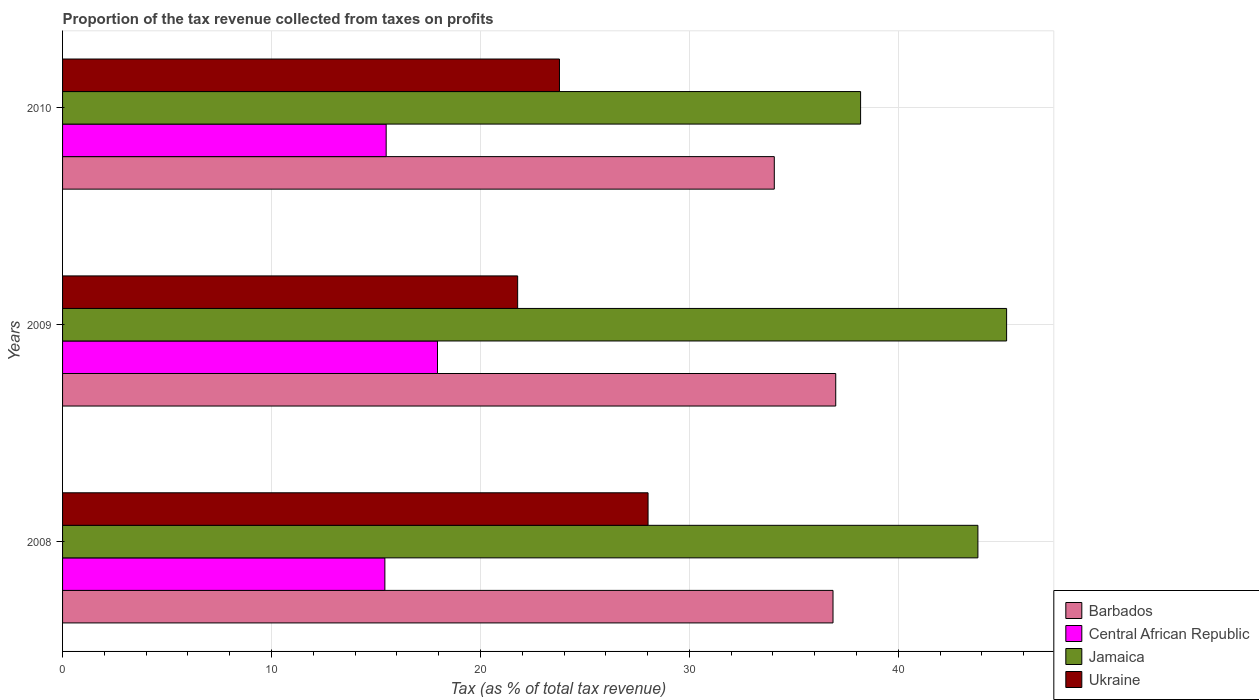How many different coloured bars are there?
Provide a short and direct response. 4. Are the number of bars on each tick of the Y-axis equal?
Your response must be concise. Yes. What is the label of the 3rd group of bars from the top?
Your answer should be very brief. 2008. In how many cases, is the number of bars for a given year not equal to the number of legend labels?
Keep it short and to the point. 0. What is the proportion of the tax revenue collected in Ukraine in 2009?
Your response must be concise. 21.78. Across all years, what is the maximum proportion of the tax revenue collected in Barbados?
Your response must be concise. 37.01. Across all years, what is the minimum proportion of the tax revenue collected in Ukraine?
Your response must be concise. 21.78. In which year was the proportion of the tax revenue collected in Jamaica minimum?
Make the answer very short. 2010. What is the total proportion of the tax revenue collected in Jamaica in the graph?
Your answer should be very brief. 127.19. What is the difference between the proportion of the tax revenue collected in Central African Republic in 2008 and that in 2009?
Give a very brief answer. -2.52. What is the difference between the proportion of the tax revenue collected in Central African Republic in 2010 and the proportion of the tax revenue collected in Jamaica in 2009?
Provide a short and direct response. -29.7. What is the average proportion of the tax revenue collected in Ukraine per year?
Your response must be concise. 24.53. In the year 2008, what is the difference between the proportion of the tax revenue collected in Ukraine and proportion of the tax revenue collected in Central African Republic?
Offer a terse response. 12.6. What is the ratio of the proportion of the tax revenue collected in Barbados in 2009 to that in 2010?
Make the answer very short. 1.09. Is the proportion of the tax revenue collected in Ukraine in 2009 less than that in 2010?
Your answer should be compact. Yes. What is the difference between the highest and the second highest proportion of the tax revenue collected in Barbados?
Provide a short and direct response. 0.13. What is the difference between the highest and the lowest proportion of the tax revenue collected in Ukraine?
Provide a succinct answer. 6.24. In how many years, is the proportion of the tax revenue collected in Ukraine greater than the average proportion of the tax revenue collected in Ukraine taken over all years?
Provide a succinct answer. 1. What does the 1st bar from the top in 2009 represents?
Keep it short and to the point. Ukraine. What does the 4th bar from the bottom in 2010 represents?
Make the answer very short. Ukraine. Is it the case that in every year, the sum of the proportion of the tax revenue collected in Barbados and proportion of the tax revenue collected in Jamaica is greater than the proportion of the tax revenue collected in Ukraine?
Your answer should be very brief. Yes. How many bars are there?
Offer a very short reply. 12. Are all the bars in the graph horizontal?
Your response must be concise. Yes. What is the title of the graph?
Your answer should be compact. Proportion of the tax revenue collected from taxes on profits. Does "Bolivia" appear as one of the legend labels in the graph?
Your response must be concise. No. What is the label or title of the X-axis?
Your response must be concise. Tax (as % of total tax revenue). What is the Tax (as % of total tax revenue) in Barbados in 2008?
Your answer should be compact. 36.88. What is the Tax (as % of total tax revenue) of Central African Republic in 2008?
Your response must be concise. 15.43. What is the Tax (as % of total tax revenue) in Jamaica in 2008?
Provide a short and direct response. 43.81. What is the Tax (as % of total tax revenue) in Ukraine in 2008?
Offer a terse response. 28.02. What is the Tax (as % of total tax revenue) in Barbados in 2009?
Your answer should be compact. 37.01. What is the Tax (as % of total tax revenue) in Central African Republic in 2009?
Your answer should be compact. 17.95. What is the Tax (as % of total tax revenue) of Jamaica in 2009?
Your answer should be very brief. 45.18. What is the Tax (as % of total tax revenue) of Ukraine in 2009?
Offer a terse response. 21.78. What is the Tax (as % of total tax revenue) in Barbados in 2010?
Your response must be concise. 34.07. What is the Tax (as % of total tax revenue) of Central African Republic in 2010?
Provide a succinct answer. 15.49. What is the Tax (as % of total tax revenue) in Jamaica in 2010?
Your answer should be very brief. 38.2. What is the Tax (as % of total tax revenue) of Ukraine in 2010?
Make the answer very short. 23.78. Across all years, what is the maximum Tax (as % of total tax revenue) in Barbados?
Your answer should be very brief. 37.01. Across all years, what is the maximum Tax (as % of total tax revenue) in Central African Republic?
Provide a succinct answer. 17.95. Across all years, what is the maximum Tax (as % of total tax revenue) of Jamaica?
Provide a short and direct response. 45.18. Across all years, what is the maximum Tax (as % of total tax revenue) in Ukraine?
Give a very brief answer. 28.02. Across all years, what is the minimum Tax (as % of total tax revenue) in Barbados?
Provide a short and direct response. 34.07. Across all years, what is the minimum Tax (as % of total tax revenue) of Central African Republic?
Ensure brevity in your answer.  15.43. Across all years, what is the minimum Tax (as % of total tax revenue) in Jamaica?
Provide a succinct answer. 38.2. Across all years, what is the minimum Tax (as % of total tax revenue) of Ukraine?
Offer a very short reply. 21.78. What is the total Tax (as % of total tax revenue) of Barbados in the graph?
Keep it short and to the point. 107.95. What is the total Tax (as % of total tax revenue) in Central African Republic in the graph?
Your answer should be very brief. 48.86. What is the total Tax (as % of total tax revenue) in Jamaica in the graph?
Offer a very short reply. 127.19. What is the total Tax (as % of total tax revenue) of Ukraine in the graph?
Your answer should be compact. 73.59. What is the difference between the Tax (as % of total tax revenue) of Barbados in 2008 and that in 2009?
Your answer should be compact. -0.13. What is the difference between the Tax (as % of total tax revenue) in Central African Republic in 2008 and that in 2009?
Your answer should be very brief. -2.52. What is the difference between the Tax (as % of total tax revenue) of Jamaica in 2008 and that in 2009?
Offer a very short reply. -1.37. What is the difference between the Tax (as % of total tax revenue) of Ukraine in 2008 and that in 2009?
Provide a short and direct response. 6.24. What is the difference between the Tax (as % of total tax revenue) in Barbados in 2008 and that in 2010?
Make the answer very short. 2.81. What is the difference between the Tax (as % of total tax revenue) in Central African Republic in 2008 and that in 2010?
Provide a succinct answer. -0.06. What is the difference between the Tax (as % of total tax revenue) in Jamaica in 2008 and that in 2010?
Offer a terse response. 5.61. What is the difference between the Tax (as % of total tax revenue) of Ukraine in 2008 and that in 2010?
Ensure brevity in your answer.  4.24. What is the difference between the Tax (as % of total tax revenue) in Barbados in 2009 and that in 2010?
Give a very brief answer. 2.94. What is the difference between the Tax (as % of total tax revenue) of Central African Republic in 2009 and that in 2010?
Your answer should be very brief. 2.46. What is the difference between the Tax (as % of total tax revenue) in Jamaica in 2009 and that in 2010?
Make the answer very short. 6.99. What is the difference between the Tax (as % of total tax revenue) in Ukraine in 2009 and that in 2010?
Provide a short and direct response. -2. What is the difference between the Tax (as % of total tax revenue) of Barbados in 2008 and the Tax (as % of total tax revenue) of Central African Republic in 2009?
Give a very brief answer. 18.93. What is the difference between the Tax (as % of total tax revenue) of Barbados in 2008 and the Tax (as % of total tax revenue) of Jamaica in 2009?
Provide a short and direct response. -8.31. What is the difference between the Tax (as % of total tax revenue) in Barbados in 2008 and the Tax (as % of total tax revenue) in Ukraine in 2009?
Offer a very short reply. 15.09. What is the difference between the Tax (as % of total tax revenue) in Central African Republic in 2008 and the Tax (as % of total tax revenue) in Jamaica in 2009?
Ensure brevity in your answer.  -29.76. What is the difference between the Tax (as % of total tax revenue) in Central African Republic in 2008 and the Tax (as % of total tax revenue) in Ukraine in 2009?
Offer a terse response. -6.35. What is the difference between the Tax (as % of total tax revenue) in Jamaica in 2008 and the Tax (as % of total tax revenue) in Ukraine in 2009?
Provide a succinct answer. 22.03. What is the difference between the Tax (as % of total tax revenue) of Barbados in 2008 and the Tax (as % of total tax revenue) of Central African Republic in 2010?
Your response must be concise. 21.39. What is the difference between the Tax (as % of total tax revenue) in Barbados in 2008 and the Tax (as % of total tax revenue) in Jamaica in 2010?
Your response must be concise. -1.32. What is the difference between the Tax (as % of total tax revenue) of Barbados in 2008 and the Tax (as % of total tax revenue) of Ukraine in 2010?
Provide a short and direct response. 13.09. What is the difference between the Tax (as % of total tax revenue) of Central African Republic in 2008 and the Tax (as % of total tax revenue) of Jamaica in 2010?
Provide a succinct answer. -22.77. What is the difference between the Tax (as % of total tax revenue) in Central African Republic in 2008 and the Tax (as % of total tax revenue) in Ukraine in 2010?
Your answer should be very brief. -8.36. What is the difference between the Tax (as % of total tax revenue) of Jamaica in 2008 and the Tax (as % of total tax revenue) of Ukraine in 2010?
Provide a succinct answer. 20.03. What is the difference between the Tax (as % of total tax revenue) of Barbados in 2009 and the Tax (as % of total tax revenue) of Central African Republic in 2010?
Offer a terse response. 21.52. What is the difference between the Tax (as % of total tax revenue) of Barbados in 2009 and the Tax (as % of total tax revenue) of Jamaica in 2010?
Keep it short and to the point. -1.19. What is the difference between the Tax (as % of total tax revenue) of Barbados in 2009 and the Tax (as % of total tax revenue) of Ukraine in 2010?
Make the answer very short. 13.22. What is the difference between the Tax (as % of total tax revenue) of Central African Republic in 2009 and the Tax (as % of total tax revenue) of Jamaica in 2010?
Your answer should be very brief. -20.25. What is the difference between the Tax (as % of total tax revenue) in Central African Republic in 2009 and the Tax (as % of total tax revenue) in Ukraine in 2010?
Make the answer very short. -5.84. What is the difference between the Tax (as % of total tax revenue) in Jamaica in 2009 and the Tax (as % of total tax revenue) in Ukraine in 2010?
Offer a terse response. 21.4. What is the average Tax (as % of total tax revenue) in Barbados per year?
Your answer should be compact. 35.98. What is the average Tax (as % of total tax revenue) of Central African Republic per year?
Provide a short and direct response. 16.29. What is the average Tax (as % of total tax revenue) in Jamaica per year?
Give a very brief answer. 42.4. What is the average Tax (as % of total tax revenue) of Ukraine per year?
Give a very brief answer. 24.53. In the year 2008, what is the difference between the Tax (as % of total tax revenue) in Barbados and Tax (as % of total tax revenue) in Central African Republic?
Provide a short and direct response. 21.45. In the year 2008, what is the difference between the Tax (as % of total tax revenue) of Barbados and Tax (as % of total tax revenue) of Jamaica?
Provide a succinct answer. -6.93. In the year 2008, what is the difference between the Tax (as % of total tax revenue) of Barbados and Tax (as % of total tax revenue) of Ukraine?
Make the answer very short. 8.85. In the year 2008, what is the difference between the Tax (as % of total tax revenue) in Central African Republic and Tax (as % of total tax revenue) in Jamaica?
Offer a very short reply. -28.38. In the year 2008, what is the difference between the Tax (as % of total tax revenue) of Central African Republic and Tax (as % of total tax revenue) of Ukraine?
Provide a short and direct response. -12.6. In the year 2008, what is the difference between the Tax (as % of total tax revenue) of Jamaica and Tax (as % of total tax revenue) of Ukraine?
Your response must be concise. 15.79. In the year 2009, what is the difference between the Tax (as % of total tax revenue) of Barbados and Tax (as % of total tax revenue) of Central African Republic?
Ensure brevity in your answer.  19.06. In the year 2009, what is the difference between the Tax (as % of total tax revenue) in Barbados and Tax (as % of total tax revenue) in Jamaica?
Make the answer very short. -8.18. In the year 2009, what is the difference between the Tax (as % of total tax revenue) in Barbados and Tax (as % of total tax revenue) in Ukraine?
Keep it short and to the point. 15.22. In the year 2009, what is the difference between the Tax (as % of total tax revenue) of Central African Republic and Tax (as % of total tax revenue) of Jamaica?
Provide a succinct answer. -27.24. In the year 2009, what is the difference between the Tax (as % of total tax revenue) in Central African Republic and Tax (as % of total tax revenue) in Ukraine?
Give a very brief answer. -3.84. In the year 2009, what is the difference between the Tax (as % of total tax revenue) of Jamaica and Tax (as % of total tax revenue) of Ukraine?
Keep it short and to the point. 23.4. In the year 2010, what is the difference between the Tax (as % of total tax revenue) in Barbados and Tax (as % of total tax revenue) in Central African Republic?
Your response must be concise. 18.58. In the year 2010, what is the difference between the Tax (as % of total tax revenue) in Barbados and Tax (as % of total tax revenue) in Jamaica?
Your answer should be very brief. -4.13. In the year 2010, what is the difference between the Tax (as % of total tax revenue) of Barbados and Tax (as % of total tax revenue) of Ukraine?
Provide a succinct answer. 10.28. In the year 2010, what is the difference between the Tax (as % of total tax revenue) of Central African Republic and Tax (as % of total tax revenue) of Jamaica?
Offer a terse response. -22.71. In the year 2010, what is the difference between the Tax (as % of total tax revenue) in Central African Republic and Tax (as % of total tax revenue) in Ukraine?
Provide a succinct answer. -8.29. In the year 2010, what is the difference between the Tax (as % of total tax revenue) of Jamaica and Tax (as % of total tax revenue) of Ukraine?
Provide a succinct answer. 14.41. What is the ratio of the Tax (as % of total tax revenue) in Central African Republic in 2008 to that in 2009?
Your response must be concise. 0.86. What is the ratio of the Tax (as % of total tax revenue) of Jamaica in 2008 to that in 2009?
Your response must be concise. 0.97. What is the ratio of the Tax (as % of total tax revenue) of Ukraine in 2008 to that in 2009?
Give a very brief answer. 1.29. What is the ratio of the Tax (as % of total tax revenue) in Barbados in 2008 to that in 2010?
Provide a short and direct response. 1.08. What is the ratio of the Tax (as % of total tax revenue) of Jamaica in 2008 to that in 2010?
Provide a short and direct response. 1.15. What is the ratio of the Tax (as % of total tax revenue) in Ukraine in 2008 to that in 2010?
Ensure brevity in your answer.  1.18. What is the ratio of the Tax (as % of total tax revenue) of Barbados in 2009 to that in 2010?
Keep it short and to the point. 1.09. What is the ratio of the Tax (as % of total tax revenue) in Central African Republic in 2009 to that in 2010?
Provide a succinct answer. 1.16. What is the ratio of the Tax (as % of total tax revenue) of Jamaica in 2009 to that in 2010?
Your answer should be very brief. 1.18. What is the ratio of the Tax (as % of total tax revenue) of Ukraine in 2009 to that in 2010?
Ensure brevity in your answer.  0.92. What is the difference between the highest and the second highest Tax (as % of total tax revenue) in Barbados?
Provide a succinct answer. 0.13. What is the difference between the highest and the second highest Tax (as % of total tax revenue) of Central African Republic?
Ensure brevity in your answer.  2.46. What is the difference between the highest and the second highest Tax (as % of total tax revenue) of Jamaica?
Provide a succinct answer. 1.37. What is the difference between the highest and the second highest Tax (as % of total tax revenue) of Ukraine?
Make the answer very short. 4.24. What is the difference between the highest and the lowest Tax (as % of total tax revenue) in Barbados?
Offer a very short reply. 2.94. What is the difference between the highest and the lowest Tax (as % of total tax revenue) of Central African Republic?
Your answer should be compact. 2.52. What is the difference between the highest and the lowest Tax (as % of total tax revenue) of Jamaica?
Your answer should be very brief. 6.99. What is the difference between the highest and the lowest Tax (as % of total tax revenue) in Ukraine?
Your answer should be very brief. 6.24. 